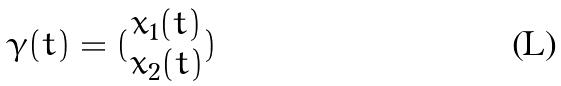<formula> <loc_0><loc_0><loc_500><loc_500>\gamma ( t ) = ( \begin{matrix} x _ { 1 } ( t ) \\ x _ { 2 } ( t ) \end{matrix} )</formula> 